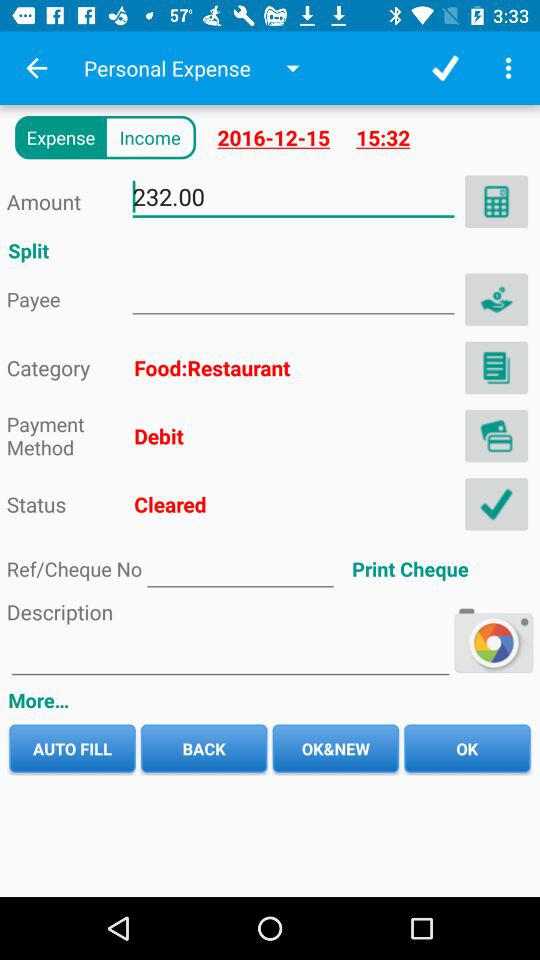What is the payment method? The payment method is by debit card. 